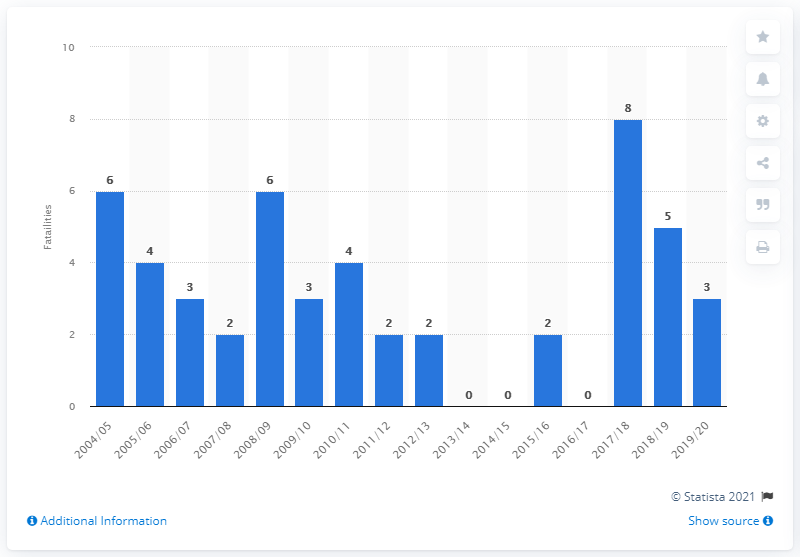Outline some significant characteristics in this image. According to records, the last time there were fatalities involving police during road traffic emergency response was in the years 2004/2005. In the 2019/2020 fiscal year, there were 3 road traffic fatalities. 